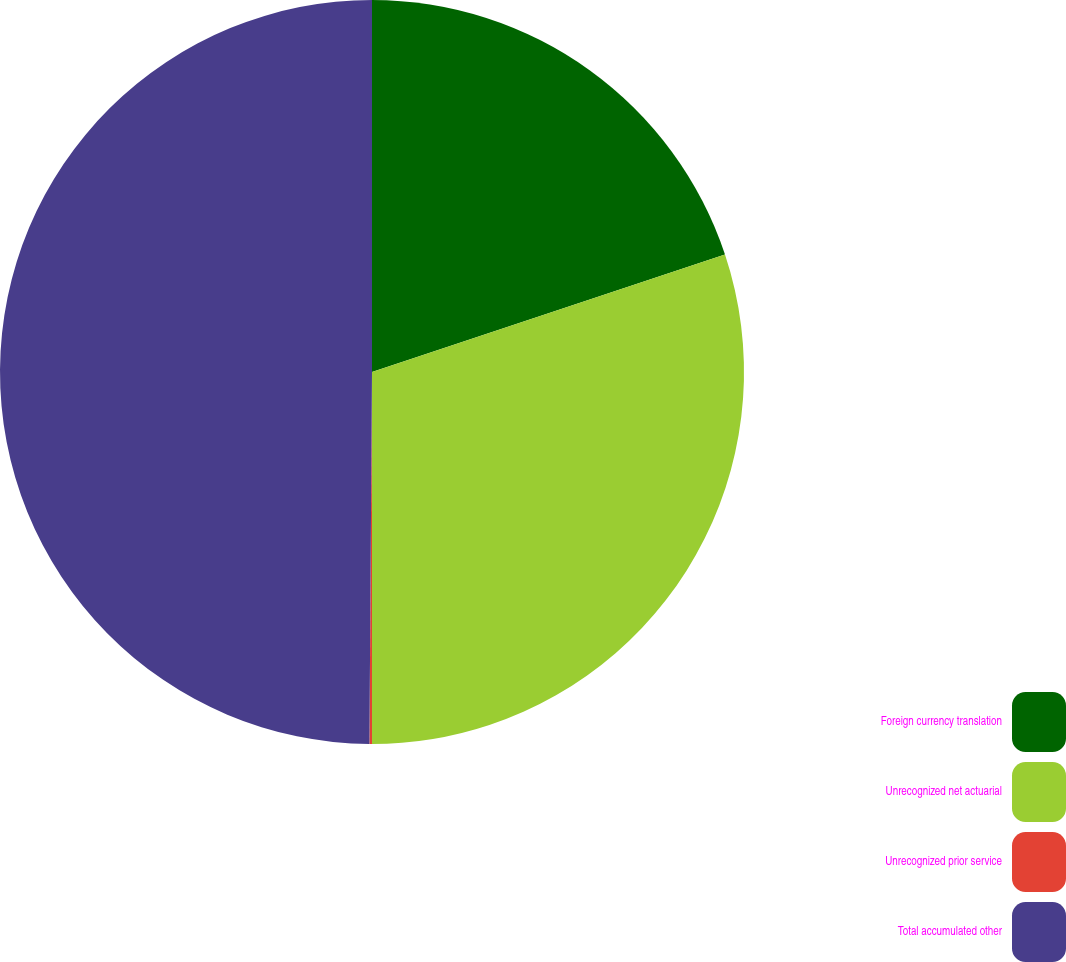<chart> <loc_0><loc_0><loc_500><loc_500><pie_chart><fcel>Foreign currency translation<fcel>Unrecognized net actuarial<fcel>Unrecognized prior service<fcel>Total accumulated other<nl><fcel>19.89%<fcel>30.11%<fcel>0.11%<fcel>49.89%<nl></chart> 